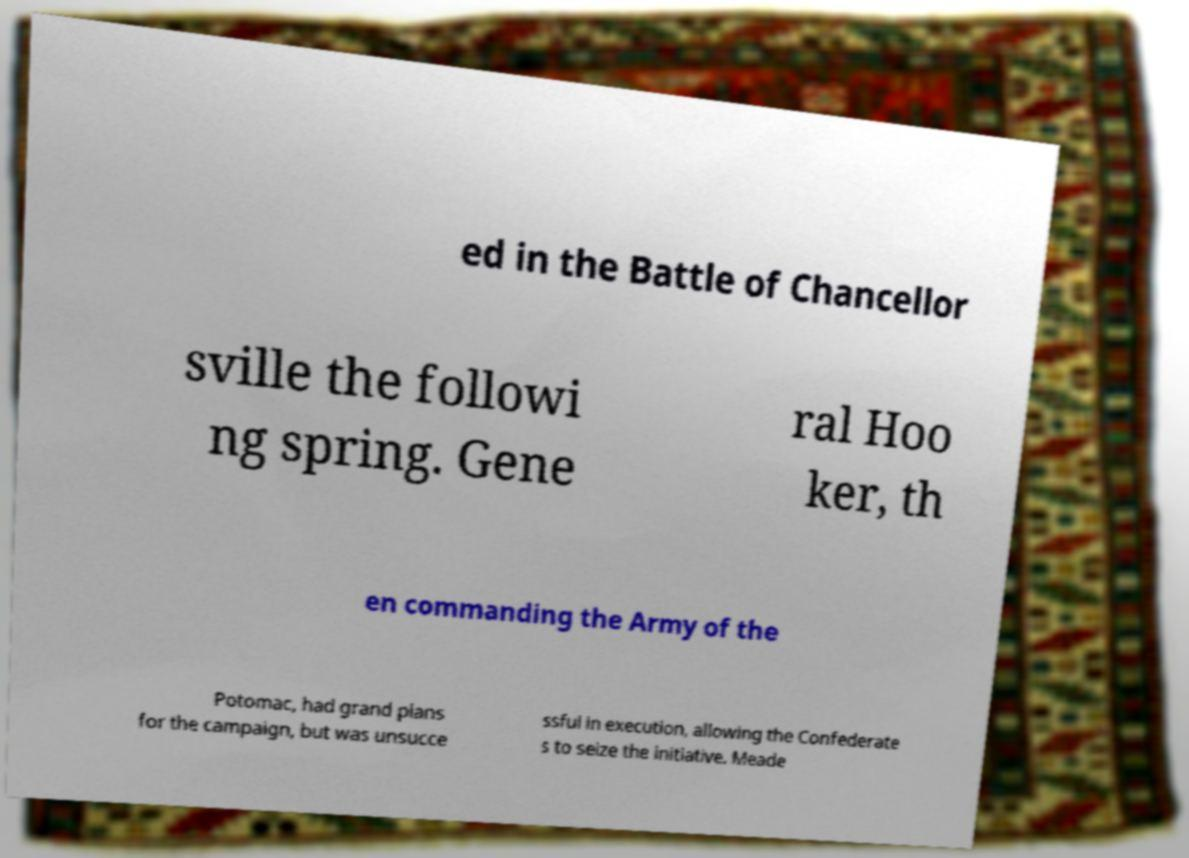Could you extract and type out the text from this image? ed in the Battle of Chancellor sville the followi ng spring. Gene ral Hoo ker, th en commanding the Army of the Potomac, had grand plans for the campaign, but was unsucce ssful in execution, allowing the Confederate s to seize the initiative. Meade 